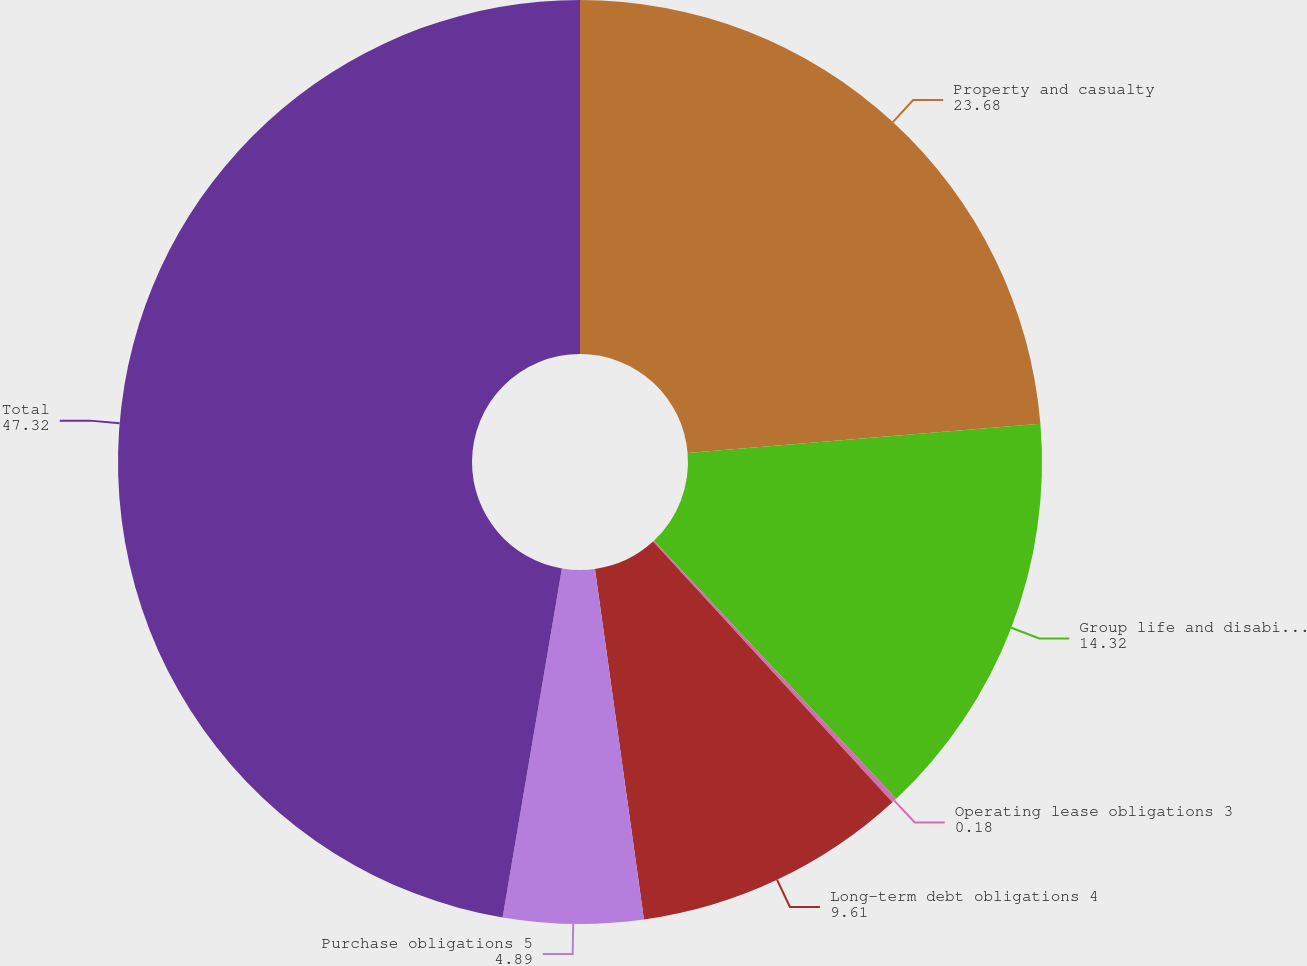Convert chart to OTSL. <chart><loc_0><loc_0><loc_500><loc_500><pie_chart><fcel>Property and casualty<fcel>Group life and disability<fcel>Operating lease obligations 3<fcel>Long-term debt obligations 4<fcel>Purchase obligations 5<fcel>Total<nl><fcel>23.68%<fcel>14.32%<fcel>0.18%<fcel>9.61%<fcel>4.89%<fcel>47.32%<nl></chart> 